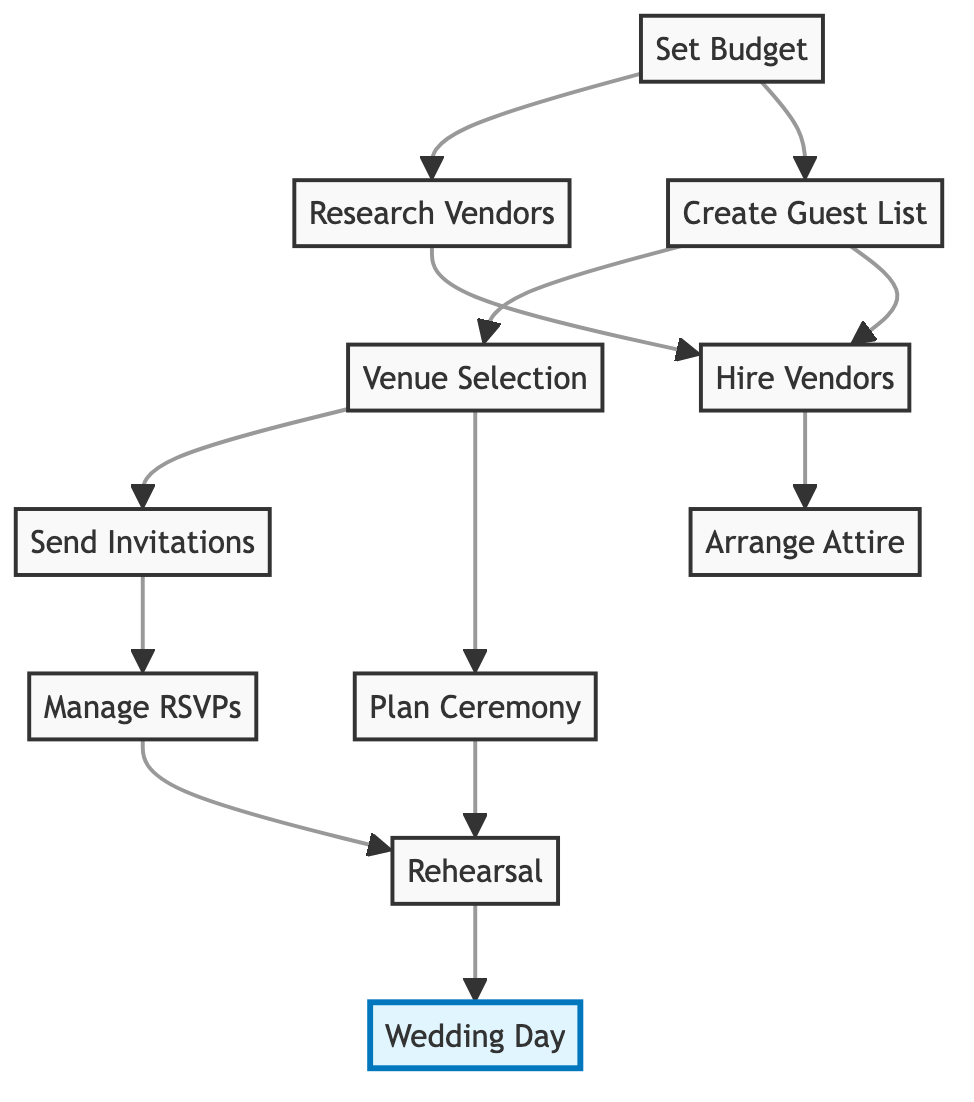What is the first node in the diagram? The first node is "Set Budget," which is the starting point for the planning process as indicated in the graph layout.
Answer: Set Budget How many nodes are present in the diagram? By counting the unique nodes listed, there are 11 nodes, each representing a different task or milestone in the wedding planning process.
Answer: 11 What is the relationship between "Create Guest List" and "Venue Selection"? "Create Guest List" points to "Venue Selection," indicating that the guest list must be compiled before selecting a venue to ensure it can accommodate the chosen guests.
Answer: Create Guest List → Venue Selection Name a milestone node in the graph. The milestone node is "Wedding Day," which is marked as the final event in the wedding planning process and signifies the culmination of all preparation efforts.
Answer: Wedding Day Which task follows "Send Invitations"? The task that follows "Send Invitations" is "Manage RSVPs," indicating that once the invitations are sent, the next step is to track responses from guests.
Answer: Manage RSVPs What is the last task before the Wedding Day? The last task before the Wedding Day is "Rehearsal," which involves organizing a run-through to ensure everything runs smoothly on the actual day.
Answer: Rehearsal How many edges connect to the "Set Budget" node? There are two edges connecting to the "Set Budget" node, pointing to "Research Vendors" and "Create Guest List," indicating these tasks stem from budget setting.
Answer: 2 Do the "Hire Vendors" and "Arrange Attire" tasks depend on each other? No, "Hire Vendors" and "Arrange Attire" do not have a direct connection between them in the diagram, meaning they can be accomplished independently of one another.
Answer: No Which task occurs after both "Plan Ceremony" and "Manage RSVPs"? The task that occurs after both "Plan Ceremony" and "Manage RSVPs" is "Rehearsal," indicating that both event planning and response management are necessary before this step.
Answer: Rehearsal 